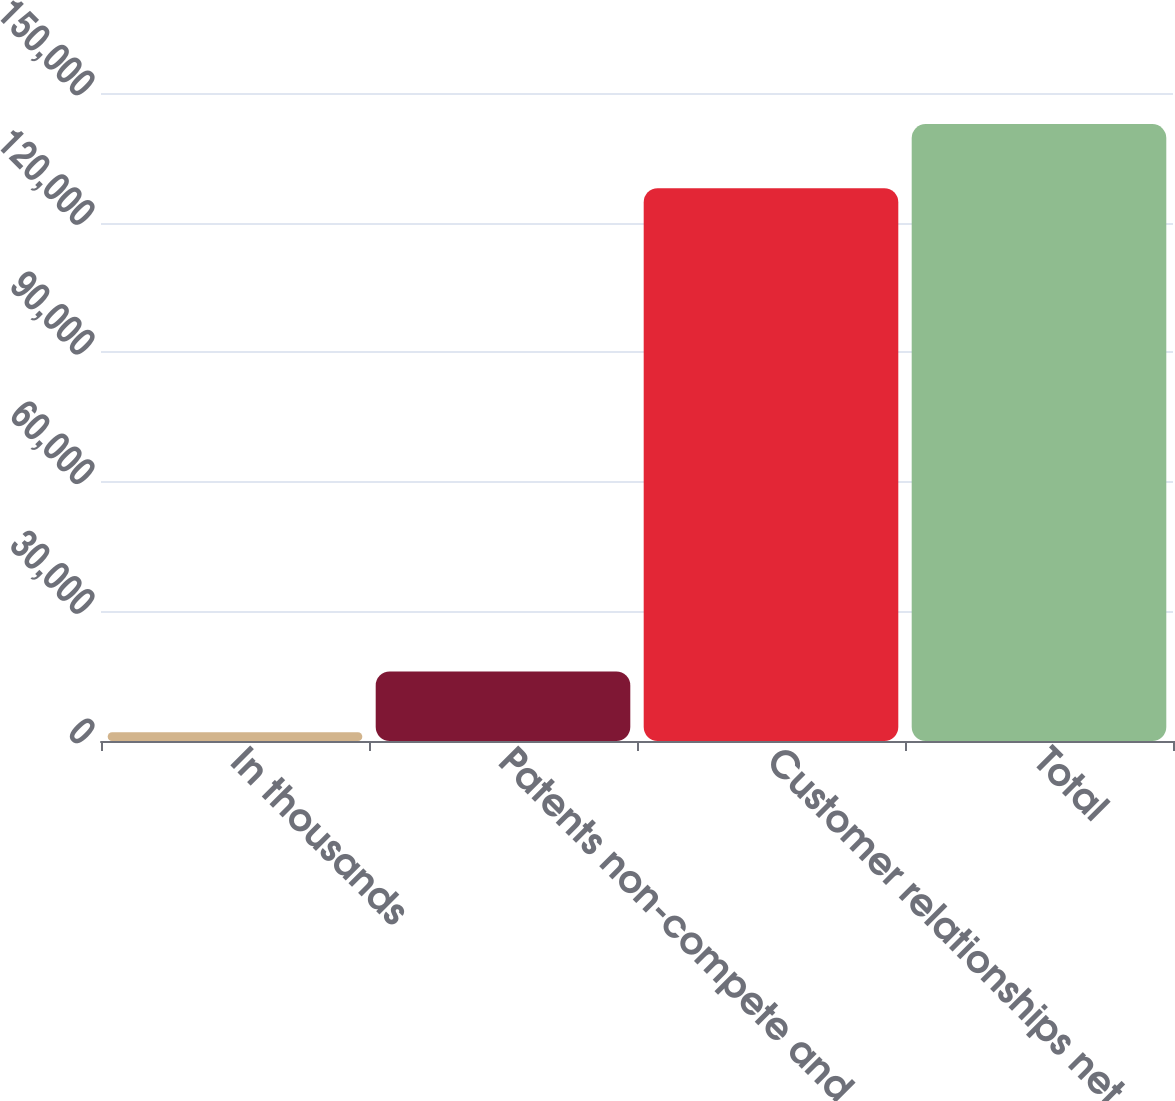<chart> <loc_0><loc_0><loc_500><loc_500><bar_chart><fcel>In thousands<fcel>Patents non-compete and other<fcel>Customer relationships net of<fcel>Total<nl><fcel>2011<fcel>16090.8<fcel>127960<fcel>142809<nl></chart> 